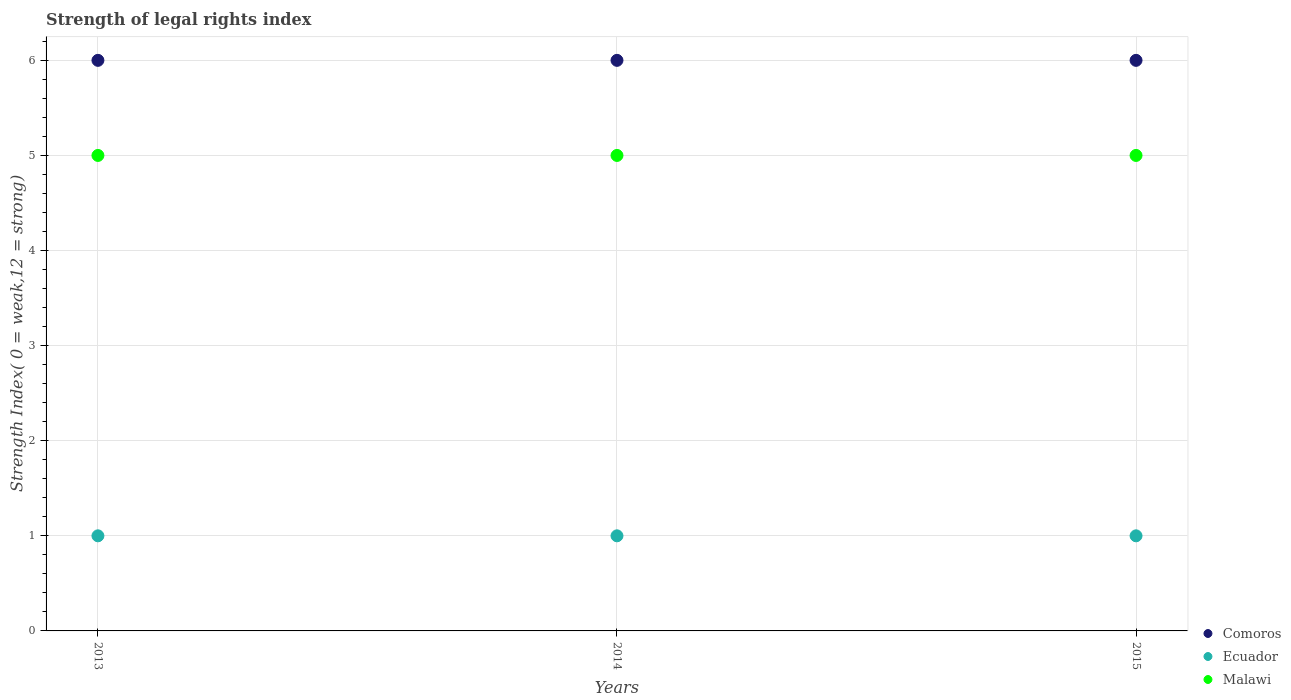How many different coloured dotlines are there?
Provide a succinct answer. 3. Is the number of dotlines equal to the number of legend labels?
Your response must be concise. Yes. What is the strength index in Ecuador in 2015?
Provide a short and direct response. 1. Across all years, what is the maximum strength index in Comoros?
Make the answer very short. 6. Across all years, what is the minimum strength index in Malawi?
Give a very brief answer. 5. In which year was the strength index in Ecuador maximum?
Provide a succinct answer. 2013. What is the total strength index in Ecuador in the graph?
Provide a short and direct response. 3. What is the difference between the strength index in Malawi in 2013 and that in 2015?
Your answer should be compact. 0. What is the difference between the strength index in Ecuador in 2015 and the strength index in Malawi in 2014?
Provide a short and direct response. -4. What is the average strength index in Ecuador per year?
Your response must be concise. 1. In the year 2015, what is the difference between the strength index in Comoros and strength index in Ecuador?
Your answer should be very brief. 5. What is the ratio of the strength index in Comoros in 2013 to that in 2015?
Provide a short and direct response. 1. Is the difference between the strength index in Comoros in 2014 and 2015 greater than the difference between the strength index in Ecuador in 2014 and 2015?
Offer a very short reply. No. What is the difference between the highest and the second highest strength index in Ecuador?
Ensure brevity in your answer.  0. What is the difference between the highest and the lowest strength index in Ecuador?
Offer a very short reply. 0. In how many years, is the strength index in Ecuador greater than the average strength index in Ecuador taken over all years?
Make the answer very short. 0. Is the strength index in Ecuador strictly less than the strength index in Comoros over the years?
Provide a short and direct response. Yes. How many dotlines are there?
Provide a succinct answer. 3. How many years are there in the graph?
Keep it short and to the point. 3. Does the graph contain any zero values?
Your answer should be very brief. No. Where does the legend appear in the graph?
Offer a very short reply. Bottom right. What is the title of the graph?
Give a very brief answer. Strength of legal rights index. Does "Nicaragua" appear as one of the legend labels in the graph?
Ensure brevity in your answer.  No. What is the label or title of the Y-axis?
Offer a terse response. Strength Index( 0 = weak,12 = strong). What is the Strength Index( 0 = weak,12 = strong) in Comoros in 2013?
Provide a succinct answer. 6. What is the Strength Index( 0 = weak,12 = strong) in Comoros in 2014?
Ensure brevity in your answer.  6. What is the Strength Index( 0 = weak,12 = strong) of Ecuador in 2014?
Your answer should be compact. 1. What is the Strength Index( 0 = weak,12 = strong) in Malawi in 2014?
Provide a succinct answer. 5. Across all years, what is the maximum Strength Index( 0 = weak,12 = strong) of Malawi?
Keep it short and to the point. 5. Across all years, what is the minimum Strength Index( 0 = weak,12 = strong) of Ecuador?
Offer a very short reply. 1. Across all years, what is the minimum Strength Index( 0 = weak,12 = strong) in Malawi?
Offer a terse response. 5. What is the total Strength Index( 0 = weak,12 = strong) of Ecuador in the graph?
Give a very brief answer. 3. What is the difference between the Strength Index( 0 = weak,12 = strong) of Ecuador in 2013 and that in 2014?
Offer a terse response. 0. What is the difference between the Strength Index( 0 = weak,12 = strong) of Malawi in 2013 and that in 2014?
Offer a terse response. 0. What is the difference between the Strength Index( 0 = weak,12 = strong) in Ecuador in 2014 and that in 2015?
Your answer should be very brief. 0. What is the difference between the Strength Index( 0 = weak,12 = strong) in Comoros in 2013 and the Strength Index( 0 = weak,12 = strong) in Malawi in 2014?
Your answer should be compact. 1. What is the difference between the Strength Index( 0 = weak,12 = strong) in Ecuador in 2013 and the Strength Index( 0 = weak,12 = strong) in Malawi in 2014?
Offer a terse response. -4. What is the difference between the Strength Index( 0 = weak,12 = strong) of Comoros in 2013 and the Strength Index( 0 = weak,12 = strong) of Malawi in 2015?
Keep it short and to the point. 1. What is the difference between the Strength Index( 0 = weak,12 = strong) of Ecuador in 2013 and the Strength Index( 0 = weak,12 = strong) of Malawi in 2015?
Your answer should be very brief. -4. What is the difference between the Strength Index( 0 = weak,12 = strong) of Comoros in 2014 and the Strength Index( 0 = weak,12 = strong) of Ecuador in 2015?
Keep it short and to the point. 5. What is the difference between the Strength Index( 0 = weak,12 = strong) of Comoros in 2014 and the Strength Index( 0 = weak,12 = strong) of Malawi in 2015?
Offer a terse response. 1. What is the average Strength Index( 0 = weak,12 = strong) of Comoros per year?
Offer a very short reply. 6. What is the average Strength Index( 0 = weak,12 = strong) of Ecuador per year?
Provide a short and direct response. 1. What is the average Strength Index( 0 = weak,12 = strong) in Malawi per year?
Keep it short and to the point. 5. In the year 2013, what is the difference between the Strength Index( 0 = weak,12 = strong) in Comoros and Strength Index( 0 = weak,12 = strong) in Ecuador?
Keep it short and to the point. 5. In the year 2014, what is the difference between the Strength Index( 0 = weak,12 = strong) in Comoros and Strength Index( 0 = weak,12 = strong) in Malawi?
Your answer should be compact. 1. In the year 2015, what is the difference between the Strength Index( 0 = weak,12 = strong) in Comoros and Strength Index( 0 = weak,12 = strong) in Ecuador?
Your response must be concise. 5. In the year 2015, what is the difference between the Strength Index( 0 = weak,12 = strong) of Comoros and Strength Index( 0 = weak,12 = strong) of Malawi?
Offer a very short reply. 1. What is the ratio of the Strength Index( 0 = weak,12 = strong) in Comoros in 2013 to that in 2014?
Provide a short and direct response. 1. What is the ratio of the Strength Index( 0 = weak,12 = strong) in Ecuador in 2013 to that in 2014?
Offer a terse response. 1. What is the ratio of the Strength Index( 0 = weak,12 = strong) of Malawi in 2013 to that in 2015?
Make the answer very short. 1. What is the ratio of the Strength Index( 0 = weak,12 = strong) of Ecuador in 2014 to that in 2015?
Give a very brief answer. 1. What is the difference between the highest and the second highest Strength Index( 0 = weak,12 = strong) of Comoros?
Make the answer very short. 0. What is the difference between the highest and the lowest Strength Index( 0 = weak,12 = strong) of Comoros?
Your answer should be compact. 0. What is the difference between the highest and the lowest Strength Index( 0 = weak,12 = strong) in Ecuador?
Make the answer very short. 0. 